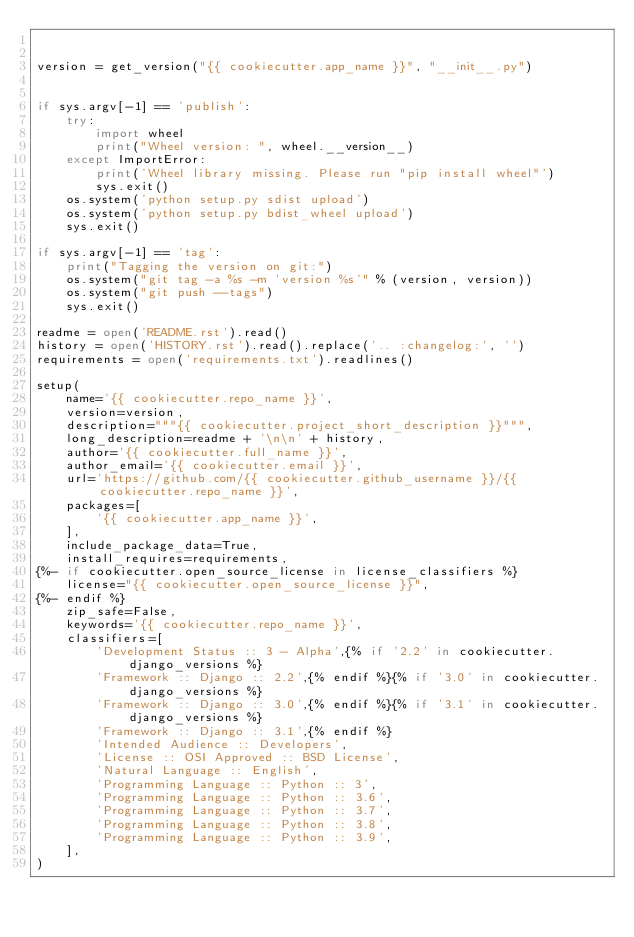<code> <loc_0><loc_0><loc_500><loc_500><_Python_>

version = get_version("{{ cookiecutter.app_name }}", "__init__.py")


if sys.argv[-1] == 'publish':
    try:
        import wheel
        print("Wheel version: ", wheel.__version__)
    except ImportError:
        print('Wheel library missing. Please run "pip install wheel"')
        sys.exit()
    os.system('python setup.py sdist upload')
    os.system('python setup.py bdist_wheel upload')
    sys.exit()

if sys.argv[-1] == 'tag':
    print("Tagging the version on git:")
    os.system("git tag -a %s -m 'version %s'" % (version, version))
    os.system("git push --tags")
    sys.exit()

readme = open('README.rst').read()
history = open('HISTORY.rst').read().replace('.. :changelog:', '')
requirements = open('requirements.txt').readlines()

setup(
    name='{{ cookiecutter.repo_name }}',
    version=version,
    description="""{{ cookiecutter.project_short_description }}""",
    long_description=readme + '\n\n' + history,
    author='{{ cookiecutter.full_name }}',
    author_email='{{ cookiecutter.email }}',
    url='https://github.com/{{ cookiecutter.github_username }}/{{ cookiecutter.repo_name }}',
    packages=[
        '{{ cookiecutter.app_name }}',
    ],
    include_package_data=True,
    install_requires=requirements,
{%- if cookiecutter.open_source_license in license_classifiers %}
    license="{{ cookiecutter.open_source_license }}",
{%- endif %}
    zip_safe=False,
    keywords='{{ cookiecutter.repo_name }}',
    classifiers=[
        'Development Status :: 3 - Alpha',{% if '2.2' in cookiecutter.django_versions %}
        'Framework :: Django :: 2.2',{% endif %}{% if '3.0' in cookiecutter.django_versions %}
        'Framework :: Django :: 3.0',{% endif %}{% if '3.1' in cookiecutter.django_versions %}
        'Framework :: Django :: 3.1',{% endif %}
        'Intended Audience :: Developers',
        'License :: OSI Approved :: BSD License',
        'Natural Language :: English',
        'Programming Language :: Python :: 3',
        'Programming Language :: Python :: 3.6',
        'Programming Language :: Python :: 3.7',
        'Programming Language :: Python :: 3.8',
        'Programming Language :: Python :: 3.9',
    ],
)
</code> 